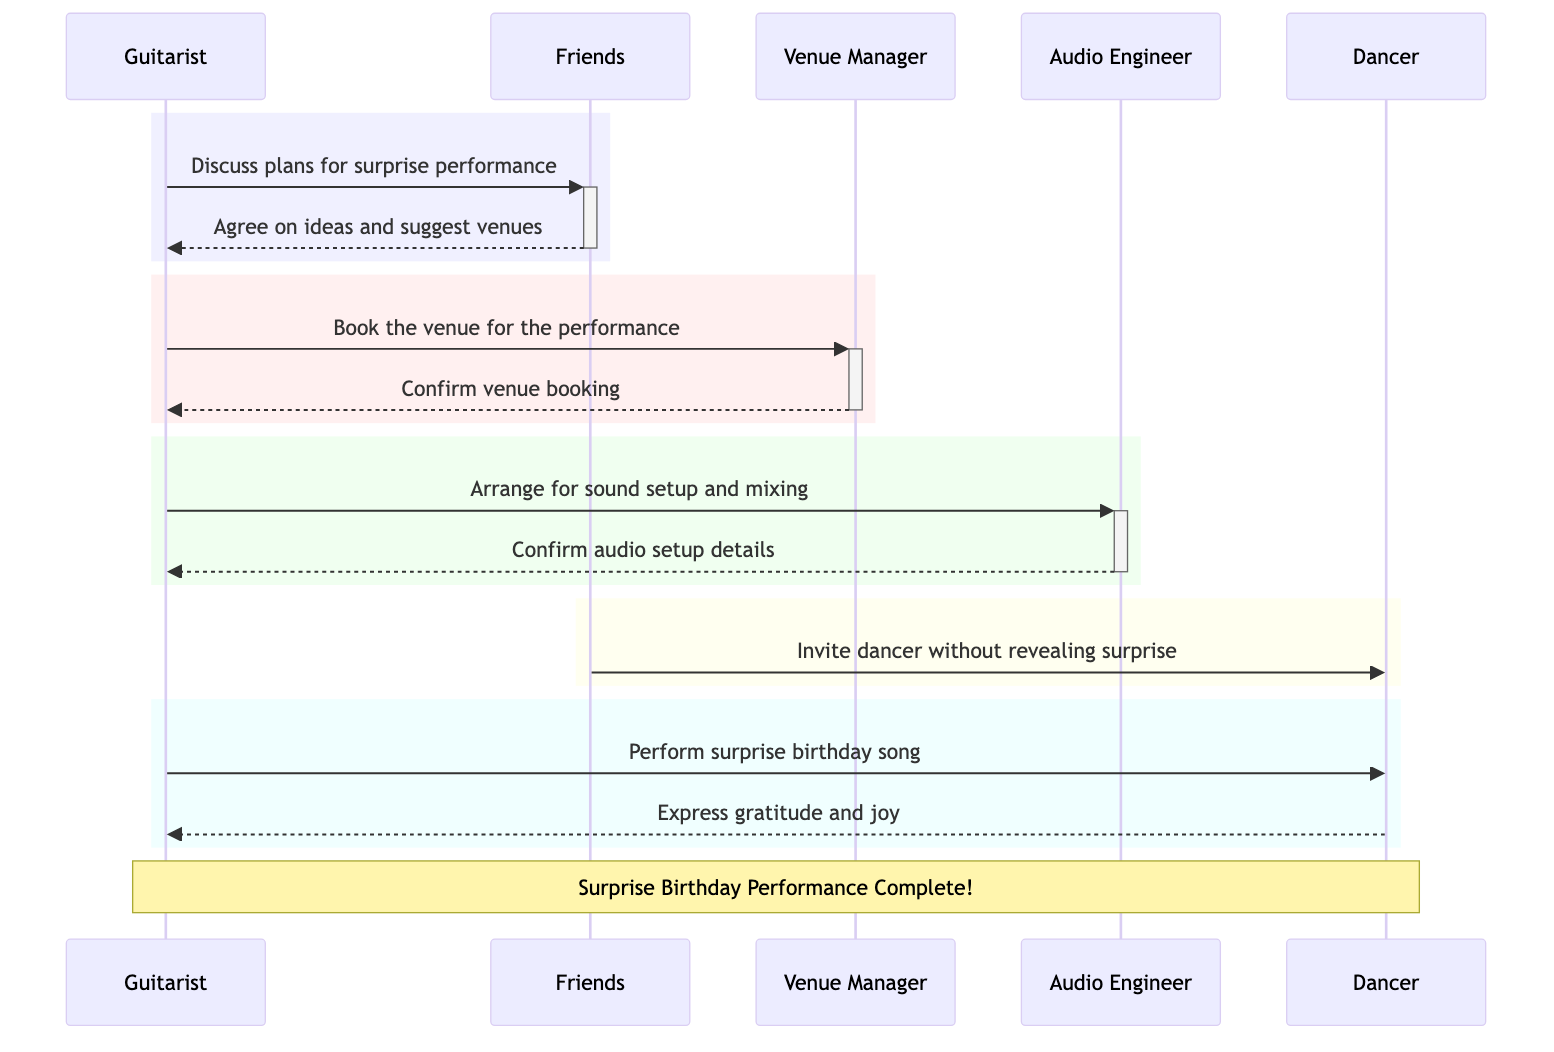What are the participants involved in the diagram? The participants listed in the diagram include Guitarist, Friends, Venue Manager, Audio Engineer, and Dancer. These roles are identified at the beginning of the sequence diagram.
Answer: Guitarist, Friends, Venue Manager, Audio Engineer, Dancer How many messages are exchanged in total? Counting all the individual messages shown in the diagram, there are a total of 8 messages exchanged between the participants.
Answer: 8 What is the first action taken in the sequence? The first action in the diagram is the Guitarist discussing plans for the surprise performance with the Friends. This is the initial message exchanged in the sequence.
Answer: Discuss plans for surprise performance Who invites the Dancer to the venue? The Friends are the ones who invite the Dancer to the venue without revealing the surprise. This can be observed in the message flow where Friends send an invitation to Dancer.
Answer: Friends What confirmation does the Audio Engineer send to the Guitarist? The Audio Engineer confirms the audio setup details to the Guitarist after the Guitarist arranges for sound setup and audio mixing. This is a critical part of the preparation for the performance.
Answer: Confirm audio setup details Which participant performs the surprise birthday song? The Guitarist is the participant who performs the surprise birthday song on stage for the Dancer, as indicated in the diagram.
Answer: Guitarist What is the final expression from the Dancer towards the Guitarist? The final expression from the Dancer towards the Guitarist is one of gratitude and joy, as indicated in the last message exchanged in the sequence.
Answer: Express gratitude and joy What action follows the confirmation of the venue booking? After the confirmation of the venue booking from the Venue Manager, the next action is for the Guitarist to arrange for sound setup and audio mixing with the Audio Engineer. This signifies the progression of planning after securing the venue.
Answer: Arrange for sound setup and mixing 